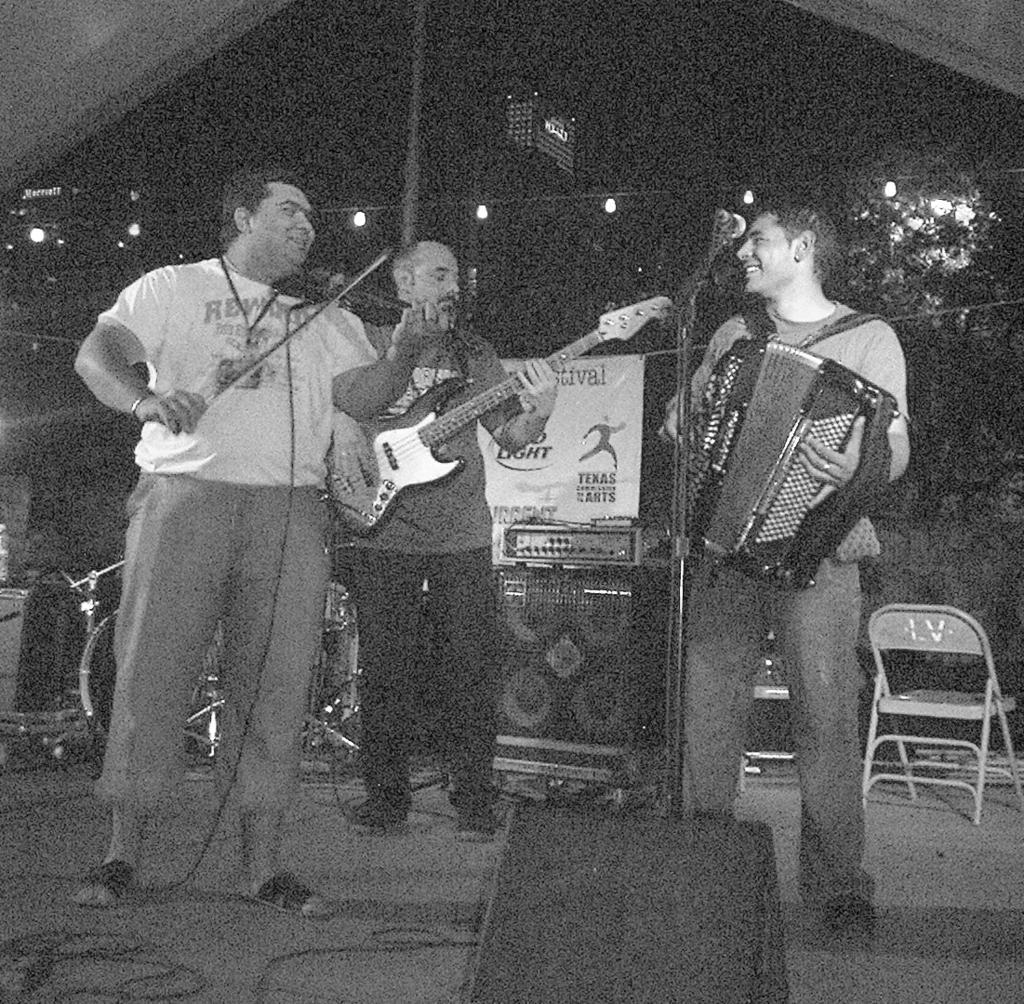Describe this image in one or two sentences. This image consist of three men. To the left, the man is playing violin. In the middle, the man is playing guitar. At the bottom, there is a speaker. In the background, there are trees and buildings. At the bottom, there is a dais. 